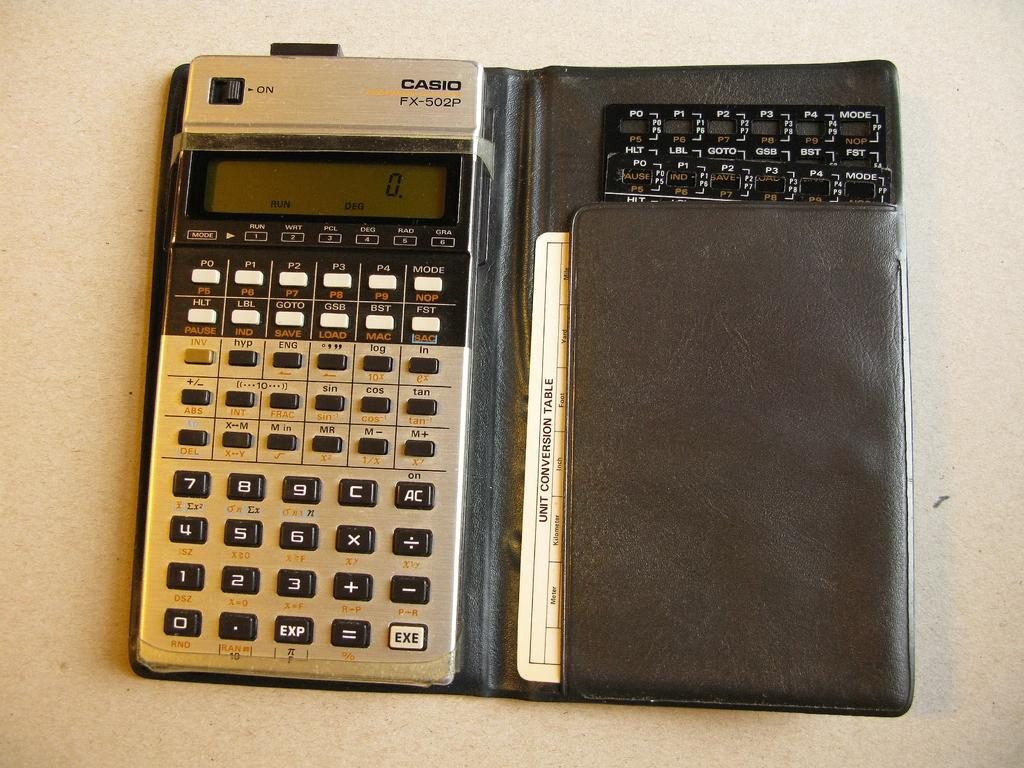<image>
Relay a brief, clear account of the picture shown. Calculator with black words that say CASIO on it. 